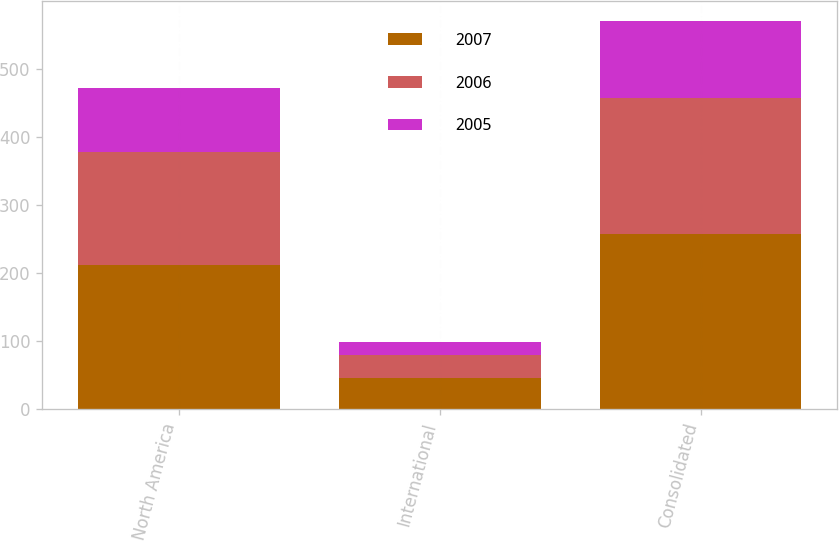<chart> <loc_0><loc_0><loc_500><loc_500><stacked_bar_chart><ecel><fcel>North America<fcel>International<fcel>Consolidated<nl><fcel>2007<fcel>212<fcel>46<fcel>258<nl><fcel>2006<fcel>166<fcel>34<fcel>200<nl><fcel>2005<fcel>94<fcel>19<fcel>113<nl></chart> 